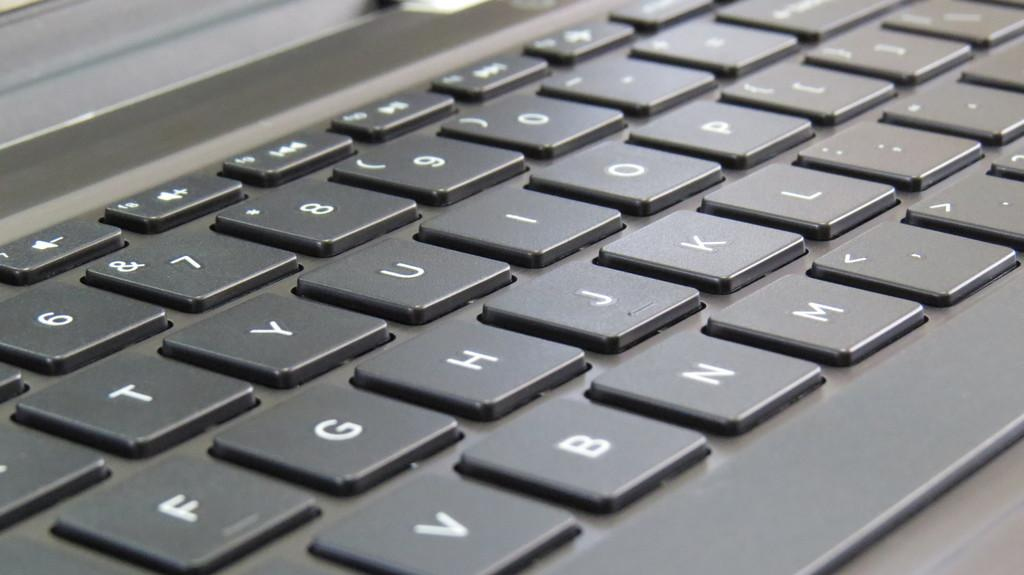<image>
Offer a succinct explanation of the picture presented. The v key is next to the b key on the keyboard 